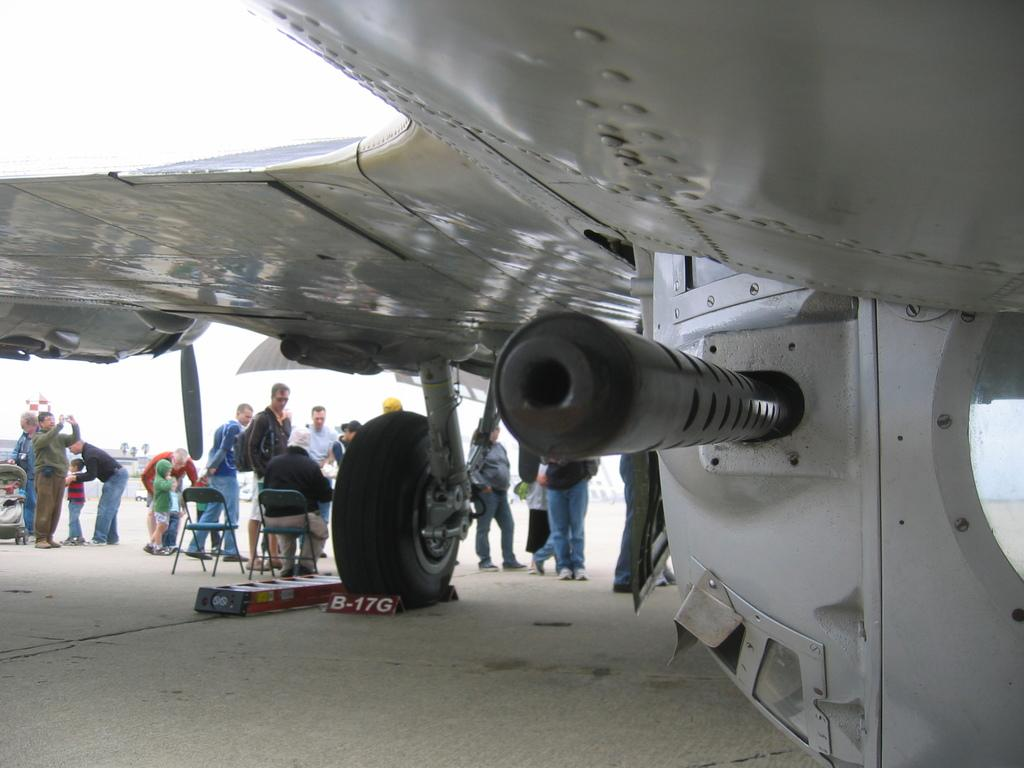<image>
Share a concise interpretation of the image provided. The block on the plane's wheel has the number B-17G. 